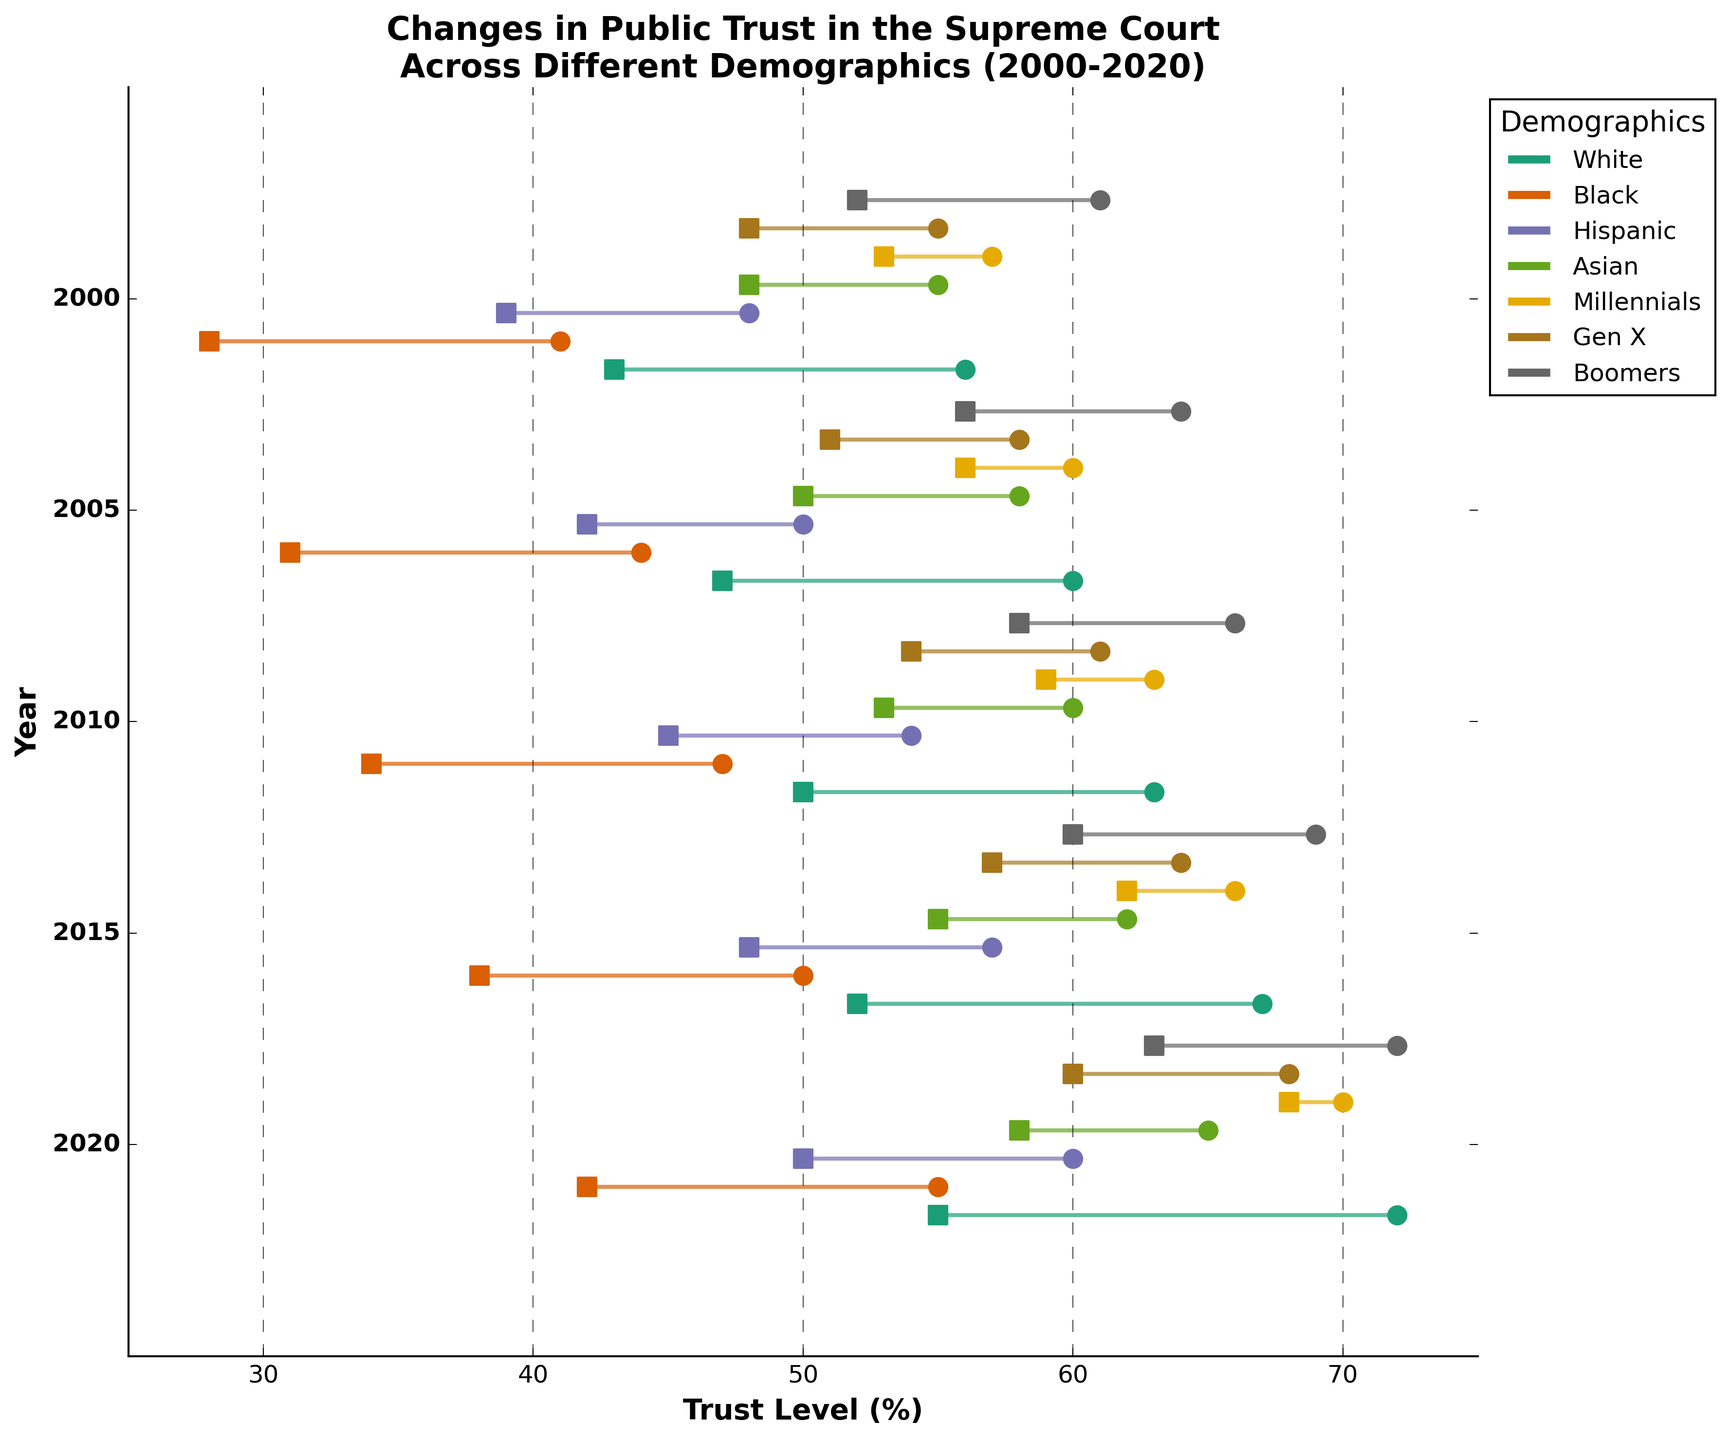What is the title of the figure? The title is located at the top of the figure in bold font. It reads: "Changes in Public Trust in the Supreme Court Across Different Demographics (2000-2020)."
Answer: Changes in Public Trust in the Supreme Court Across Different Demographics (2000-2020) What is the trust level range on the x-axis? The x-axis represents the trust level percentages, labeled from 25% to 75%. The tick marks and grid lines provide a clear range across this axis.
Answer: 25 to 75 How did the trust level of Boomers change from 2000 to 2020? By examining the two points connected by the line for Boomers in the plot from 2000 to 2020, the trust level decreased from 72% to 52%.
Answer: Decreased from 72% to 52% Which demographic had the lowest trust level in 2020? By observing the endpoints of the lines for each demographic in 2020, the Black demographic has the lowest end point at 28%.
Answer: Black Which demographic showed the smallest decrease in trust level from 2000 to 2020? To find this, calculate the difference between the trust levels for each demographic from 2000 to 2020 and compare. Millennials had a decrease from 70% to 53%, the smallest change of 17%.
Answer: Millennials How many demographics are represented in the figure? The legend on the right side of the figure lists all the demographics represented. You can count the unique items listed.
Answer: 8 What is the difference in trust level for Hispanics between the starting and ending points in 2015? For Hispanics in 2015, the trust level starts at 50% and ends at 42%. The difference is 50% - 42% = 8%.
Answer: 8% Did any demographic's trust level increase over any time period? Examining the dumbbell plots for all demographics across all years, none show an increase; all lines show a decrease in trust level from start to end points.
Answer: No Which demographic had a greater decrease in trust level from 2000 to 2020, Gen X or Boomers? Compare the decrease: Gen X went from 68% to 48% (20% decrease) and Boomers from 72% to 52% (20% decrease). Both had the same decrease.
Answer: Same (20%) 